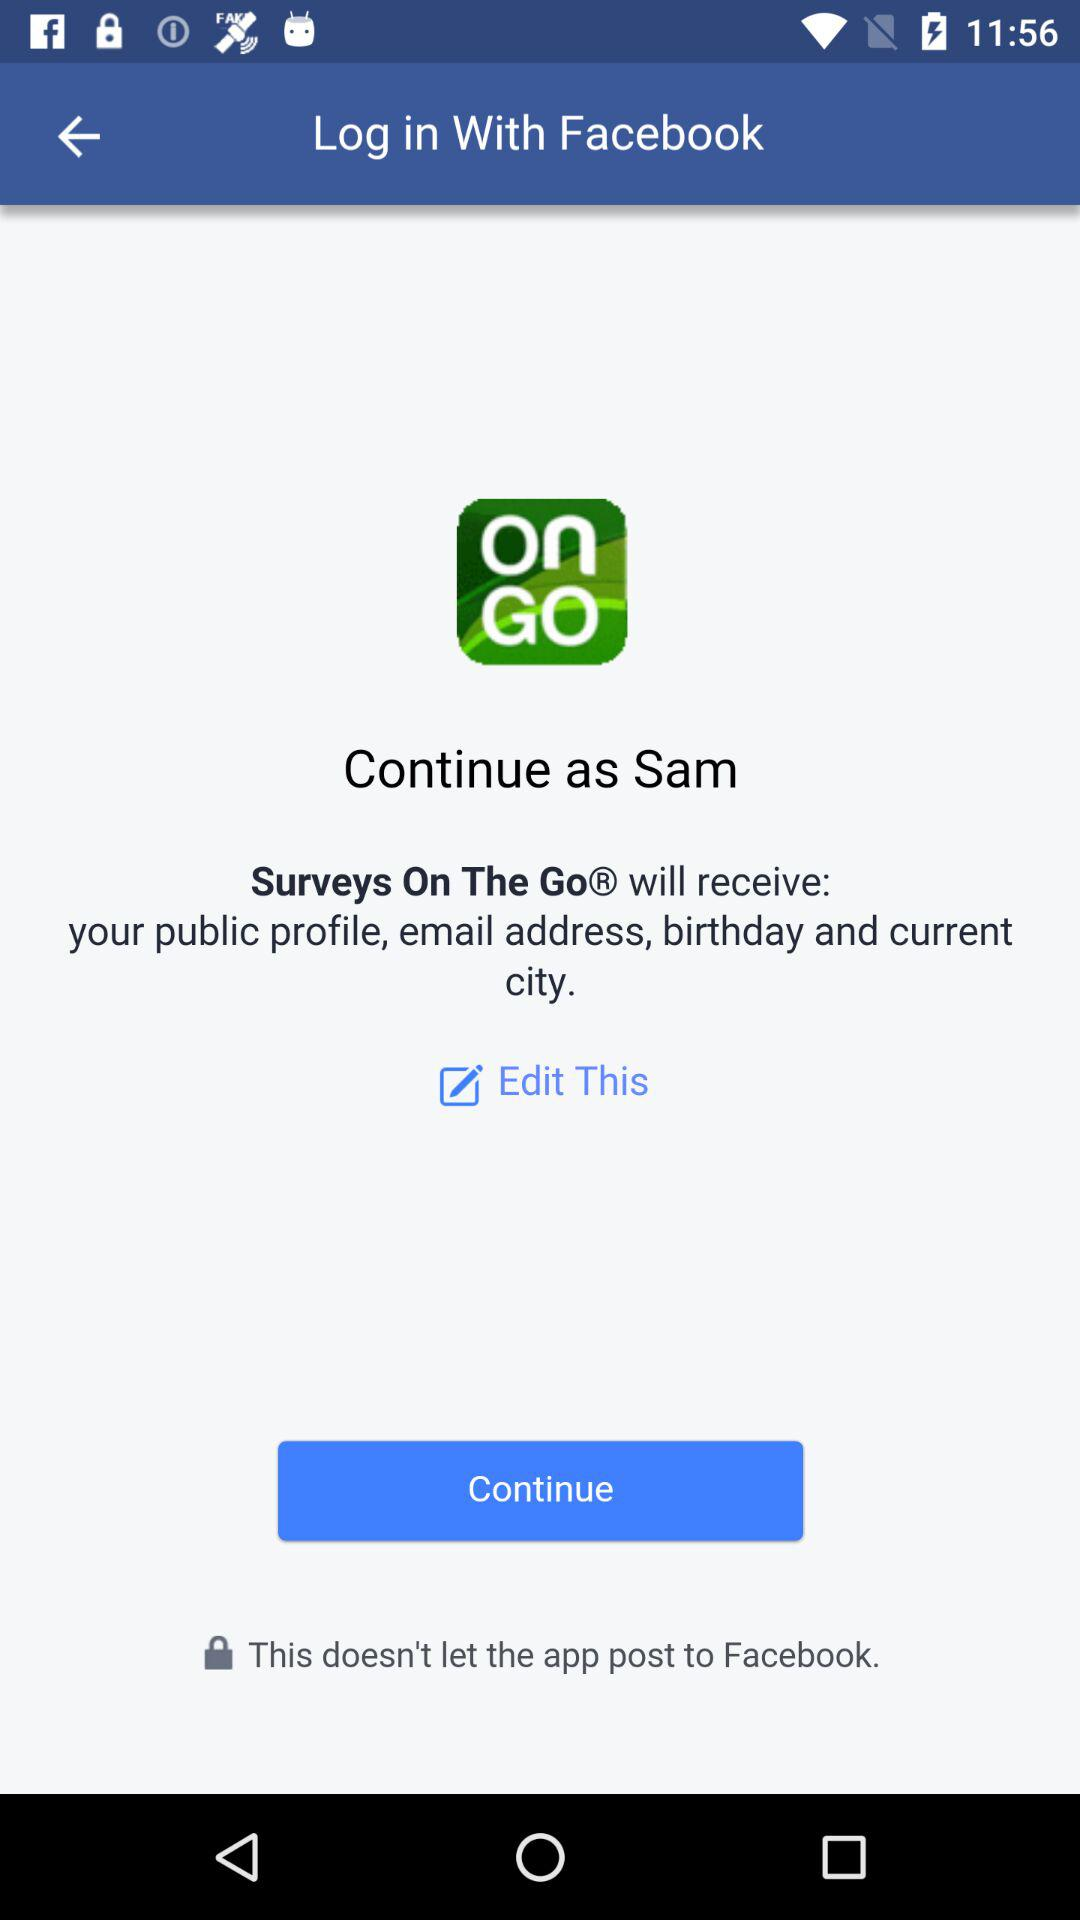What is the user's last name?
When the provided information is insufficient, respond with <no answer>. <no answer> 